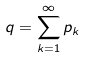<formula> <loc_0><loc_0><loc_500><loc_500>q = \sum _ { k = 1 } ^ { \infty } p _ { k }</formula> 